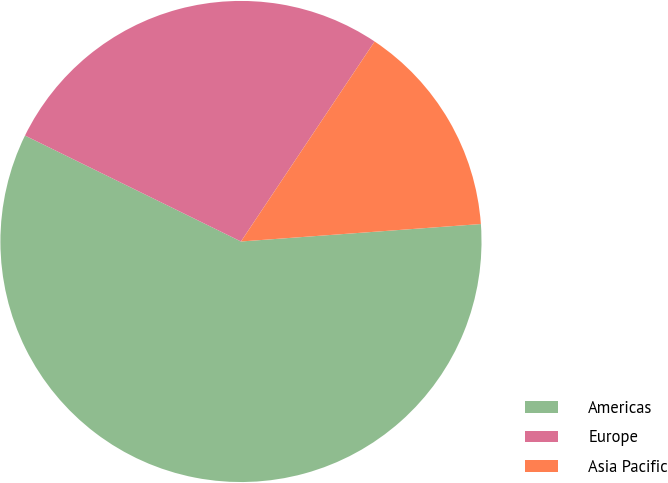Convert chart. <chart><loc_0><loc_0><loc_500><loc_500><pie_chart><fcel>Americas<fcel>Europe<fcel>Asia Pacific<nl><fcel>58.42%<fcel>27.12%<fcel>14.47%<nl></chart> 